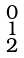<formula> <loc_0><loc_0><loc_500><loc_500>\begin{smallmatrix} 0 \\ 1 \\ 2 \end{smallmatrix}</formula> 